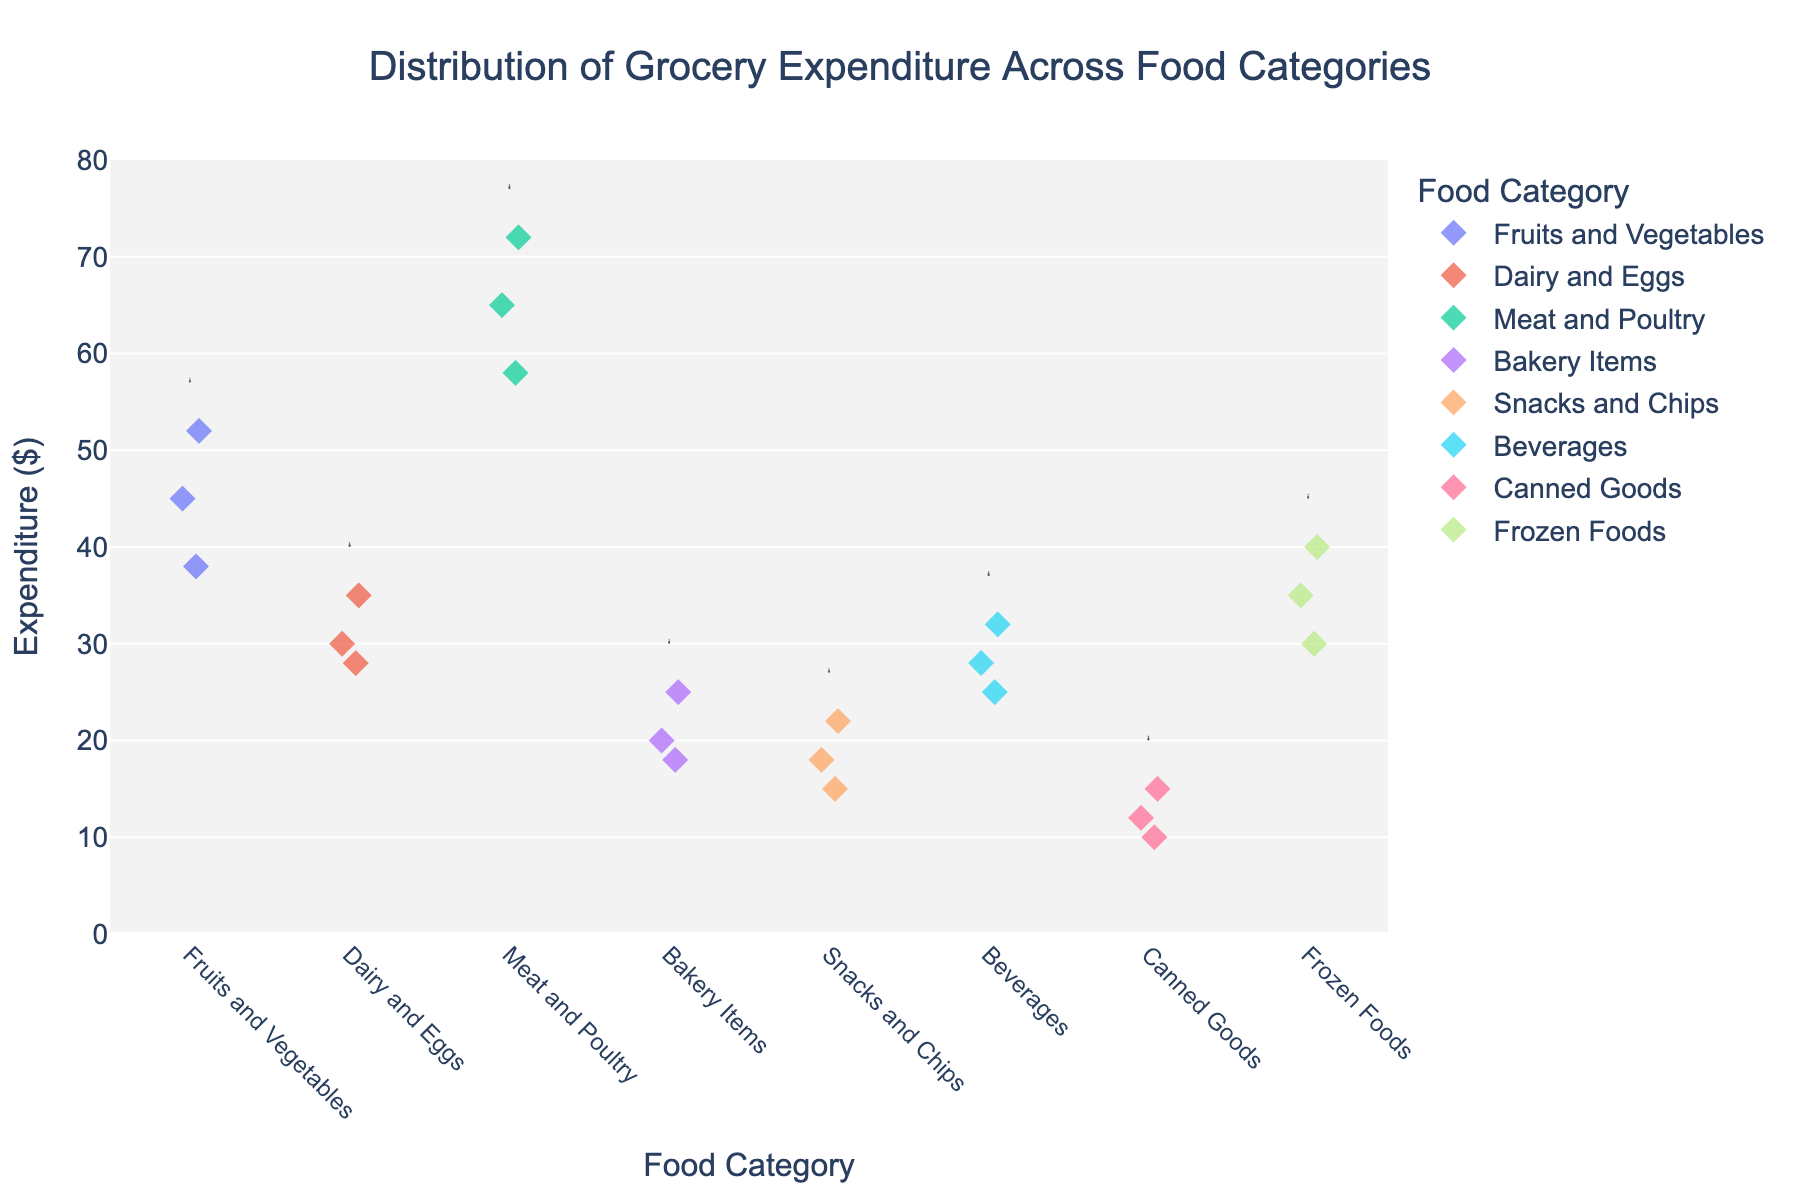What's the title of the figure? The title is usually placed at the top of the figure. In this case, it is stated within the code in the 'title' parameter of the plotly figure creation function.
Answer: Distribution of Grocery Expenditure Across Food Categories How many food categories are shown in the plot? In the code, the 'Category' column values represent different food categories. Based on this, there are seven unique categories.
Answer: 7 What is the highest expenditure on Meat and Poultry? We look at the value markers for Meat and Poultry and find the maximum y-value.
Answer: 72 Which category has the lowest expenditure? Find the category whose lowest data point is the smallest among all categories. Canned Goods has an expenditure as low as 10 based on the plot data.
Answer: Canned Goods What is the average expenditure on Dairy and Eggs? Sum the expenditures on Dairy and Eggs (30 + 35 + 28) and then divide by the number of data points which is 3. (30 + 35 + 28)/3 = 31
Answer: 31 Which food category has the most consistent expenditure distribution? Check the spread of data points (tightness of values). Snacks and Chips appear to have values (15,18,22) more tightly packed.
Answer: Snacks and Chips Compare the highest expenditure in Bakery Items to that in Frozen Foods. Which one is higher? Find the highest expenditure in both categories and compare: Bakery Items (25) vs Frozen Foods (40), Frozen Foods is higher.
Answer: Frozen Foods What's the total expenditure for Beverages? Sum the given expenditures for Beverages (28 + 32 + 25). (28 + 32 + 25) = 85
Answer: 85 Which category has a wider range of expenditure values, Fruits and Vegetables, or Snacks and Chips? Calculate the range (max-min) for both: Fruits and Vegetables (52-38=14) and Snacks and Chips (22-15=7). Fruits and Vegetables have a wider range.
Answer: Fruits and Vegetables Is the median expenditure of Fruits and Vegetables higher than that of Dairy and Eggs? Median of Fruits and Vegetables (38, 45, 52) is 45. Median of Dairy and Eggs (28, 30, 35) is 30.
Answer: Yes 